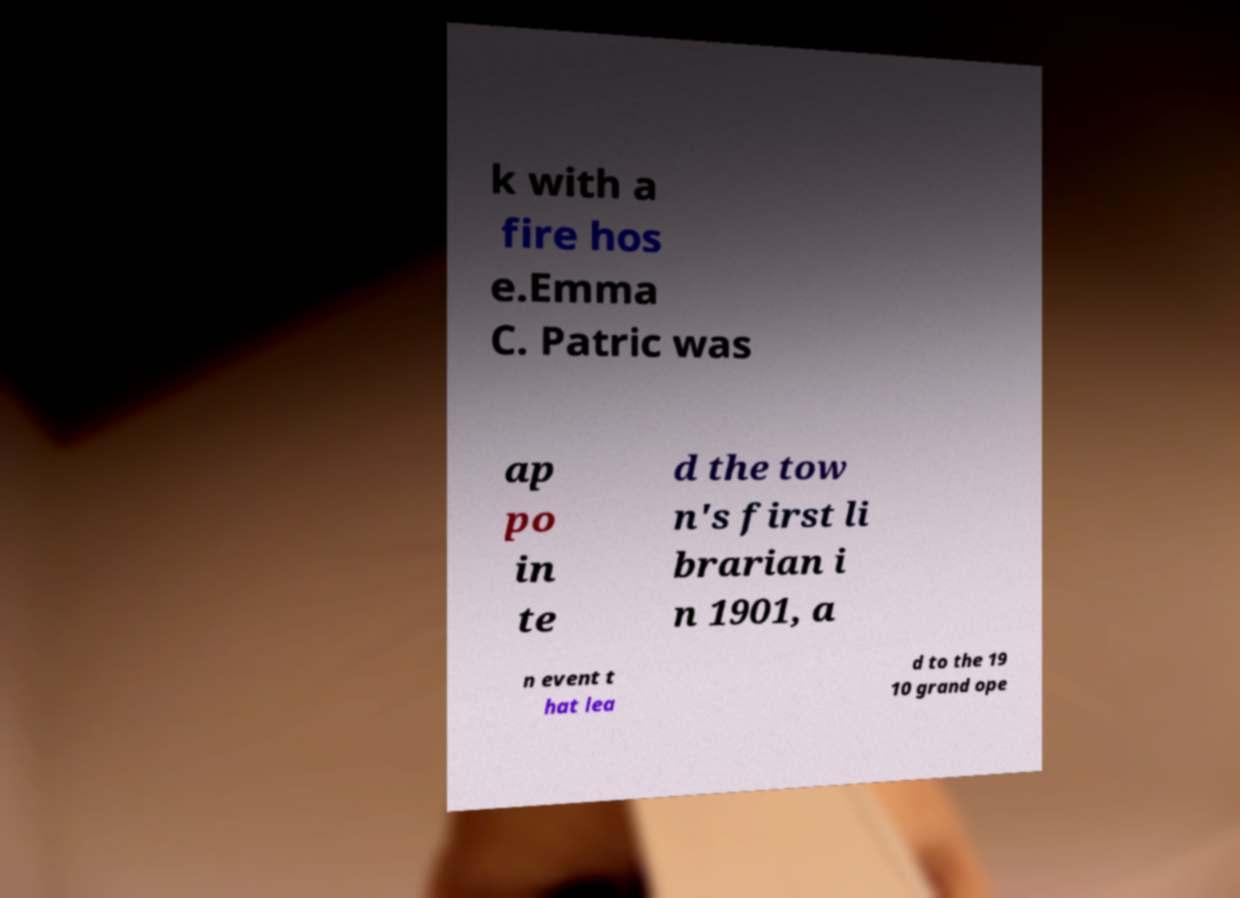For documentation purposes, I need the text within this image transcribed. Could you provide that? k with a fire hos e.Emma C. Patric was ap po in te d the tow n's first li brarian i n 1901, a n event t hat lea d to the 19 10 grand ope 